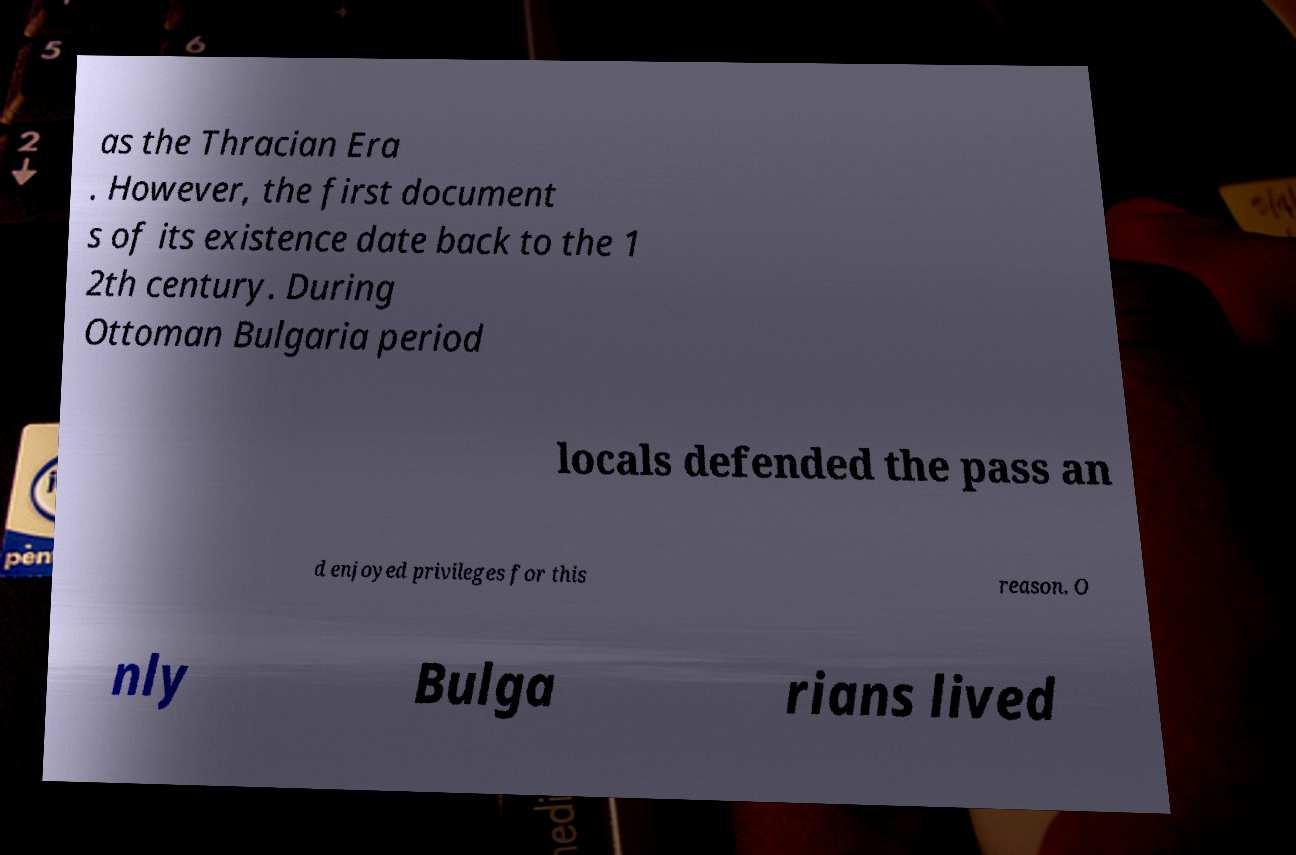Can you explain what the 'Thracian Era' mentioned in the image refers to? The 'Thracian Era' refers to the period linked to the Thracians, an ancient group who lived in what is now Bulgaria and parts of Greece and Turkey before and during the time of the Roman Empire. This era is noted for its distinct culture and contributions to the region, especially in terms of art and craftsmanship. 